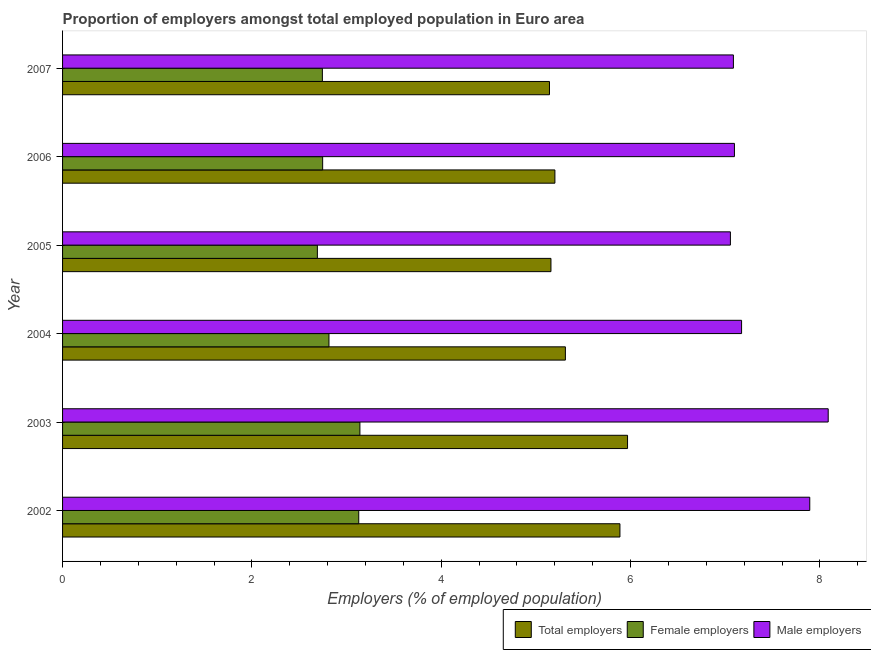How many different coloured bars are there?
Give a very brief answer. 3. How many bars are there on the 6th tick from the bottom?
Offer a very short reply. 3. In how many cases, is the number of bars for a given year not equal to the number of legend labels?
Your response must be concise. 0. What is the percentage of male employers in 2004?
Offer a terse response. 7.17. Across all years, what is the maximum percentage of female employers?
Offer a terse response. 3.14. Across all years, what is the minimum percentage of female employers?
Ensure brevity in your answer.  2.69. In which year was the percentage of female employers minimum?
Give a very brief answer. 2005. What is the total percentage of male employers in the graph?
Your answer should be compact. 44.39. What is the difference between the percentage of total employers in 2002 and that in 2004?
Give a very brief answer. 0.58. What is the difference between the percentage of total employers in 2003 and the percentage of male employers in 2006?
Provide a succinct answer. -1.13. What is the average percentage of female employers per year?
Your answer should be very brief. 2.88. In the year 2007, what is the difference between the percentage of male employers and percentage of female employers?
Your response must be concise. 4.34. What is the ratio of the percentage of total employers in 2003 to that in 2005?
Your response must be concise. 1.16. Is the difference between the percentage of female employers in 2002 and 2006 greater than the difference between the percentage of male employers in 2002 and 2006?
Make the answer very short. No. What is the difference between the highest and the second highest percentage of female employers?
Provide a succinct answer. 0.01. What is the difference between the highest and the lowest percentage of total employers?
Provide a short and direct response. 0.82. Is the sum of the percentage of female employers in 2003 and 2007 greater than the maximum percentage of male employers across all years?
Your response must be concise. No. What does the 3rd bar from the top in 2003 represents?
Ensure brevity in your answer.  Total employers. What does the 3rd bar from the bottom in 2007 represents?
Provide a succinct answer. Male employers. Is it the case that in every year, the sum of the percentage of total employers and percentage of female employers is greater than the percentage of male employers?
Ensure brevity in your answer.  Yes. How many bars are there?
Provide a succinct answer. 18. Does the graph contain any zero values?
Ensure brevity in your answer.  No. Where does the legend appear in the graph?
Give a very brief answer. Bottom right. How are the legend labels stacked?
Your answer should be compact. Horizontal. What is the title of the graph?
Offer a terse response. Proportion of employers amongst total employed population in Euro area. Does "Financial account" appear as one of the legend labels in the graph?
Provide a succinct answer. No. What is the label or title of the X-axis?
Offer a terse response. Employers (% of employed population). What is the label or title of the Y-axis?
Your answer should be very brief. Year. What is the Employers (% of employed population) in Total employers in 2002?
Ensure brevity in your answer.  5.89. What is the Employers (% of employed population) of Female employers in 2002?
Your answer should be very brief. 3.13. What is the Employers (% of employed population) of Male employers in 2002?
Make the answer very short. 7.89. What is the Employers (% of employed population) of Total employers in 2003?
Make the answer very short. 5.97. What is the Employers (% of employed population) in Female employers in 2003?
Your response must be concise. 3.14. What is the Employers (% of employed population) of Male employers in 2003?
Provide a succinct answer. 8.09. What is the Employers (% of employed population) in Total employers in 2004?
Make the answer very short. 5.31. What is the Employers (% of employed population) in Female employers in 2004?
Make the answer very short. 2.81. What is the Employers (% of employed population) of Male employers in 2004?
Keep it short and to the point. 7.17. What is the Employers (% of employed population) of Total employers in 2005?
Your answer should be very brief. 5.16. What is the Employers (% of employed population) in Female employers in 2005?
Keep it short and to the point. 2.69. What is the Employers (% of employed population) of Male employers in 2005?
Provide a succinct answer. 7.05. What is the Employers (% of employed population) in Total employers in 2006?
Offer a very short reply. 5.2. What is the Employers (% of employed population) in Female employers in 2006?
Offer a very short reply. 2.75. What is the Employers (% of employed population) in Male employers in 2006?
Your answer should be compact. 7.1. What is the Employers (% of employed population) in Total employers in 2007?
Make the answer very short. 5.14. What is the Employers (% of employed population) in Female employers in 2007?
Your answer should be compact. 2.74. What is the Employers (% of employed population) of Male employers in 2007?
Provide a short and direct response. 7.09. Across all years, what is the maximum Employers (% of employed population) in Total employers?
Make the answer very short. 5.97. Across all years, what is the maximum Employers (% of employed population) in Female employers?
Make the answer very short. 3.14. Across all years, what is the maximum Employers (% of employed population) in Male employers?
Offer a very short reply. 8.09. Across all years, what is the minimum Employers (% of employed population) of Total employers?
Make the answer very short. 5.14. Across all years, what is the minimum Employers (% of employed population) in Female employers?
Keep it short and to the point. 2.69. Across all years, what is the minimum Employers (% of employed population) in Male employers?
Provide a short and direct response. 7.05. What is the total Employers (% of employed population) in Total employers in the graph?
Your response must be concise. 32.67. What is the total Employers (% of employed population) in Female employers in the graph?
Offer a very short reply. 17.27. What is the total Employers (% of employed population) in Male employers in the graph?
Offer a very short reply. 44.39. What is the difference between the Employers (% of employed population) in Total employers in 2002 and that in 2003?
Offer a terse response. -0.08. What is the difference between the Employers (% of employed population) in Female employers in 2002 and that in 2003?
Your response must be concise. -0.01. What is the difference between the Employers (% of employed population) in Male employers in 2002 and that in 2003?
Your answer should be compact. -0.19. What is the difference between the Employers (% of employed population) in Total employers in 2002 and that in 2004?
Keep it short and to the point. 0.58. What is the difference between the Employers (% of employed population) in Female employers in 2002 and that in 2004?
Offer a terse response. 0.31. What is the difference between the Employers (% of employed population) in Male employers in 2002 and that in 2004?
Offer a very short reply. 0.72. What is the difference between the Employers (% of employed population) in Total employers in 2002 and that in 2005?
Give a very brief answer. 0.73. What is the difference between the Employers (% of employed population) in Female employers in 2002 and that in 2005?
Your answer should be very brief. 0.44. What is the difference between the Employers (% of employed population) in Male employers in 2002 and that in 2005?
Your answer should be very brief. 0.84. What is the difference between the Employers (% of employed population) in Total employers in 2002 and that in 2006?
Make the answer very short. 0.69. What is the difference between the Employers (% of employed population) of Female employers in 2002 and that in 2006?
Your answer should be very brief. 0.38. What is the difference between the Employers (% of employed population) in Male employers in 2002 and that in 2006?
Your response must be concise. 0.8. What is the difference between the Employers (% of employed population) of Total employers in 2002 and that in 2007?
Your answer should be very brief. 0.74. What is the difference between the Employers (% of employed population) of Female employers in 2002 and that in 2007?
Provide a short and direct response. 0.38. What is the difference between the Employers (% of employed population) in Male employers in 2002 and that in 2007?
Keep it short and to the point. 0.81. What is the difference between the Employers (% of employed population) of Total employers in 2003 and that in 2004?
Keep it short and to the point. 0.66. What is the difference between the Employers (% of employed population) of Female employers in 2003 and that in 2004?
Provide a succinct answer. 0.33. What is the difference between the Employers (% of employed population) in Male employers in 2003 and that in 2004?
Keep it short and to the point. 0.92. What is the difference between the Employers (% of employed population) in Total employers in 2003 and that in 2005?
Keep it short and to the point. 0.81. What is the difference between the Employers (% of employed population) in Female employers in 2003 and that in 2005?
Your answer should be very brief. 0.45. What is the difference between the Employers (% of employed population) of Male employers in 2003 and that in 2005?
Your answer should be compact. 1.03. What is the difference between the Employers (% of employed population) of Total employers in 2003 and that in 2006?
Your answer should be compact. 0.77. What is the difference between the Employers (% of employed population) of Female employers in 2003 and that in 2006?
Your answer should be compact. 0.39. What is the difference between the Employers (% of employed population) in Male employers in 2003 and that in 2006?
Provide a succinct answer. 0.99. What is the difference between the Employers (% of employed population) of Total employers in 2003 and that in 2007?
Your answer should be compact. 0.82. What is the difference between the Employers (% of employed population) in Female employers in 2003 and that in 2007?
Ensure brevity in your answer.  0.4. What is the difference between the Employers (% of employed population) of Total employers in 2004 and that in 2005?
Provide a succinct answer. 0.15. What is the difference between the Employers (% of employed population) of Female employers in 2004 and that in 2005?
Offer a very short reply. 0.12. What is the difference between the Employers (% of employed population) in Male employers in 2004 and that in 2005?
Give a very brief answer. 0.12. What is the difference between the Employers (% of employed population) of Total employers in 2004 and that in 2006?
Offer a terse response. 0.11. What is the difference between the Employers (% of employed population) of Female employers in 2004 and that in 2006?
Your answer should be very brief. 0.07. What is the difference between the Employers (% of employed population) of Male employers in 2004 and that in 2006?
Your answer should be very brief. 0.08. What is the difference between the Employers (% of employed population) in Total employers in 2004 and that in 2007?
Give a very brief answer. 0.17. What is the difference between the Employers (% of employed population) of Female employers in 2004 and that in 2007?
Keep it short and to the point. 0.07. What is the difference between the Employers (% of employed population) of Male employers in 2004 and that in 2007?
Make the answer very short. 0.09. What is the difference between the Employers (% of employed population) in Total employers in 2005 and that in 2006?
Provide a short and direct response. -0.04. What is the difference between the Employers (% of employed population) of Female employers in 2005 and that in 2006?
Provide a short and direct response. -0.06. What is the difference between the Employers (% of employed population) of Male employers in 2005 and that in 2006?
Your answer should be compact. -0.04. What is the difference between the Employers (% of employed population) of Total employers in 2005 and that in 2007?
Make the answer very short. 0.02. What is the difference between the Employers (% of employed population) in Female employers in 2005 and that in 2007?
Make the answer very short. -0.05. What is the difference between the Employers (% of employed population) in Male employers in 2005 and that in 2007?
Your answer should be very brief. -0.03. What is the difference between the Employers (% of employed population) in Total employers in 2006 and that in 2007?
Make the answer very short. 0.06. What is the difference between the Employers (% of employed population) in Female employers in 2006 and that in 2007?
Provide a short and direct response. 0. What is the difference between the Employers (% of employed population) in Male employers in 2006 and that in 2007?
Offer a very short reply. 0.01. What is the difference between the Employers (% of employed population) in Total employers in 2002 and the Employers (% of employed population) in Female employers in 2003?
Your response must be concise. 2.75. What is the difference between the Employers (% of employed population) in Total employers in 2002 and the Employers (% of employed population) in Male employers in 2003?
Provide a short and direct response. -2.2. What is the difference between the Employers (% of employed population) of Female employers in 2002 and the Employers (% of employed population) of Male employers in 2003?
Your answer should be compact. -4.96. What is the difference between the Employers (% of employed population) of Total employers in 2002 and the Employers (% of employed population) of Female employers in 2004?
Keep it short and to the point. 3.07. What is the difference between the Employers (% of employed population) in Total employers in 2002 and the Employers (% of employed population) in Male employers in 2004?
Ensure brevity in your answer.  -1.28. What is the difference between the Employers (% of employed population) of Female employers in 2002 and the Employers (% of employed population) of Male employers in 2004?
Make the answer very short. -4.04. What is the difference between the Employers (% of employed population) in Total employers in 2002 and the Employers (% of employed population) in Female employers in 2005?
Provide a succinct answer. 3.2. What is the difference between the Employers (% of employed population) in Total employers in 2002 and the Employers (% of employed population) in Male employers in 2005?
Offer a very short reply. -1.17. What is the difference between the Employers (% of employed population) of Female employers in 2002 and the Employers (% of employed population) of Male employers in 2005?
Give a very brief answer. -3.93. What is the difference between the Employers (% of employed population) of Total employers in 2002 and the Employers (% of employed population) of Female employers in 2006?
Provide a succinct answer. 3.14. What is the difference between the Employers (% of employed population) of Total employers in 2002 and the Employers (% of employed population) of Male employers in 2006?
Your response must be concise. -1.21. What is the difference between the Employers (% of employed population) in Female employers in 2002 and the Employers (% of employed population) in Male employers in 2006?
Provide a short and direct response. -3.97. What is the difference between the Employers (% of employed population) of Total employers in 2002 and the Employers (% of employed population) of Female employers in 2007?
Ensure brevity in your answer.  3.14. What is the difference between the Employers (% of employed population) in Total employers in 2002 and the Employers (% of employed population) in Male employers in 2007?
Ensure brevity in your answer.  -1.2. What is the difference between the Employers (% of employed population) of Female employers in 2002 and the Employers (% of employed population) of Male employers in 2007?
Your answer should be compact. -3.96. What is the difference between the Employers (% of employed population) of Total employers in 2003 and the Employers (% of employed population) of Female employers in 2004?
Your answer should be very brief. 3.15. What is the difference between the Employers (% of employed population) of Total employers in 2003 and the Employers (% of employed population) of Male employers in 2004?
Your answer should be very brief. -1.2. What is the difference between the Employers (% of employed population) in Female employers in 2003 and the Employers (% of employed population) in Male employers in 2004?
Give a very brief answer. -4.03. What is the difference between the Employers (% of employed population) of Total employers in 2003 and the Employers (% of employed population) of Female employers in 2005?
Your response must be concise. 3.28. What is the difference between the Employers (% of employed population) in Total employers in 2003 and the Employers (% of employed population) in Male employers in 2005?
Keep it short and to the point. -1.09. What is the difference between the Employers (% of employed population) in Female employers in 2003 and the Employers (% of employed population) in Male employers in 2005?
Provide a succinct answer. -3.91. What is the difference between the Employers (% of employed population) of Total employers in 2003 and the Employers (% of employed population) of Female employers in 2006?
Your response must be concise. 3.22. What is the difference between the Employers (% of employed population) of Total employers in 2003 and the Employers (% of employed population) of Male employers in 2006?
Ensure brevity in your answer.  -1.13. What is the difference between the Employers (% of employed population) of Female employers in 2003 and the Employers (% of employed population) of Male employers in 2006?
Your response must be concise. -3.96. What is the difference between the Employers (% of employed population) in Total employers in 2003 and the Employers (% of employed population) in Female employers in 2007?
Keep it short and to the point. 3.22. What is the difference between the Employers (% of employed population) in Total employers in 2003 and the Employers (% of employed population) in Male employers in 2007?
Your response must be concise. -1.12. What is the difference between the Employers (% of employed population) in Female employers in 2003 and the Employers (% of employed population) in Male employers in 2007?
Ensure brevity in your answer.  -3.95. What is the difference between the Employers (% of employed population) of Total employers in 2004 and the Employers (% of employed population) of Female employers in 2005?
Offer a very short reply. 2.62. What is the difference between the Employers (% of employed population) in Total employers in 2004 and the Employers (% of employed population) in Male employers in 2005?
Offer a terse response. -1.74. What is the difference between the Employers (% of employed population) of Female employers in 2004 and the Employers (% of employed population) of Male employers in 2005?
Give a very brief answer. -4.24. What is the difference between the Employers (% of employed population) in Total employers in 2004 and the Employers (% of employed population) in Female employers in 2006?
Provide a succinct answer. 2.56. What is the difference between the Employers (% of employed population) of Total employers in 2004 and the Employers (% of employed population) of Male employers in 2006?
Provide a succinct answer. -1.79. What is the difference between the Employers (% of employed population) of Female employers in 2004 and the Employers (% of employed population) of Male employers in 2006?
Ensure brevity in your answer.  -4.28. What is the difference between the Employers (% of employed population) of Total employers in 2004 and the Employers (% of employed population) of Female employers in 2007?
Make the answer very short. 2.57. What is the difference between the Employers (% of employed population) of Total employers in 2004 and the Employers (% of employed population) of Male employers in 2007?
Your answer should be compact. -1.77. What is the difference between the Employers (% of employed population) of Female employers in 2004 and the Employers (% of employed population) of Male employers in 2007?
Provide a succinct answer. -4.27. What is the difference between the Employers (% of employed population) of Total employers in 2005 and the Employers (% of employed population) of Female employers in 2006?
Give a very brief answer. 2.41. What is the difference between the Employers (% of employed population) in Total employers in 2005 and the Employers (% of employed population) in Male employers in 2006?
Your answer should be very brief. -1.94. What is the difference between the Employers (% of employed population) of Female employers in 2005 and the Employers (% of employed population) of Male employers in 2006?
Provide a short and direct response. -4.41. What is the difference between the Employers (% of employed population) of Total employers in 2005 and the Employers (% of employed population) of Female employers in 2007?
Make the answer very short. 2.41. What is the difference between the Employers (% of employed population) in Total employers in 2005 and the Employers (% of employed population) in Male employers in 2007?
Offer a terse response. -1.93. What is the difference between the Employers (% of employed population) in Female employers in 2005 and the Employers (% of employed population) in Male employers in 2007?
Make the answer very short. -4.39. What is the difference between the Employers (% of employed population) in Total employers in 2006 and the Employers (% of employed population) in Female employers in 2007?
Offer a very short reply. 2.46. What is the difference between the Employers (% of employed population) of Total employers in 2006 and the Employers (% of employed population) of Male employers in 2007?
Ensure brevity in your answer.  -1.89. What is the difference between the Employers (% of employed population) in Female employers in 2006 and the Employers (% of employed population) in Male employers in 2007?
Offer a terse response. -4.34. What is the average Employers (% of employed population) in Total employers per year?
Offer a very short reply. 5.45. What is the average Employers (% of employed population) of Female employers per year?
Provide a succinct answer. 2.88. What is the average Employers (% of employed population) in Male employers per year?
Keep it short and to the point. 7.4. In the year 2002, what is the difference between the Employers (% of employed population) in Total employers and Employers (% of employed population) in Female employers?
Provide a succinct answer. 2.76. In the year 2002, what is the difference between the Employers (% of employed population) of Total employers and Employers (% of employed population) of Male employers?
Offer a very short reply. -2.01. In the year 2002, what is the difference between the Employers (% of employed population) in Female employers and Employers (% of employed population) in Male employers?
Your answer should be very brief. -4.76. In the year 2003, what is the difference between the Employers (% of employed population) of Total employers and Employers (% of employed population) of Female employers?
Make the answer very short. 2.83. In the year 2003, what is the difference between the Employers (% of employed population) in Total employers and Employers (% of employed population) in Male employers?
Your response must be concise. -2.12. In the year 2003, what is the difference between the Employers (% of employed population) in Female employers and Employers (% of employed population) in Male employers?
Keep it short and to the point. -4.95. In the year 2004, what is the difference between the Employers (% of employed population) of Total employers and Employers (% of employed population) of Female employers?
Make the answer very short. 2.5. In the year 2004, what is the difference between the Employers (% of employed population) of Total employers and Employers (% of employed population) of Male employers?
Provide a short and direct response. -1.86. In the year 2004, what is the difference between the Employers (% of employed population) of Female employers and Employers (% of employed population) of Male employers?
Offer a very short reply. -4.36. In the year 2005, what is the difference between the Employers (% of employed population) of Total employers and Employers (% of employed population) of Female employers?
Offer a terse response. 2.47. In the year 2005, what is the difference between the Employers (% of employed population) in Total employers and Employers (% of employed population) in Male employers?
Make the answer very short. -1.9. In the year 2005, what is the difference between the Employers (% of employed population) in Female employers and Employers (% of employed population) in Male employers?
Your answer should be compact. -4.36. In the year 2006, what is the difference between the Employers (% of employed population) of Total employers and Employers (% of employed population) of Female employers?
Provide a short and direct response. 2.45. In the year 2006, what is the difference between the Employers (% of employed population) of Total employers and Employers (% of employed population) of Male employers?
Provide a short and direct response. -1.9. In the year 2006, what is the difference between the Employers (% of employed population) of Female employers and Employers (% of employed population) of Male employers?
Offer a very short reply. -4.35. In the year 2007, what is the difference between the Employers (% of employed population) of Total employers and Employers (% of employed population) of Female employers?
Make the answer very short. 2.4. In the year 2007, what is the difference between the Employers (% of employed population) in Total employers and Employers (% of employed population) in Male employers?
Your answer should be compact. -1.94. In the year 2007, what is the difference between the Employers (% of employed population) of Female employers and Employers (% of employed population) of Male employers?
Keep it short and to the point. -4.34. What is the ratio of the Employers (% of employed population) in Total employers in 2002 to that in 2003?
Offer a very short reply. 0.99. What is the ratio of the Employers (% of employed population) in Male employers in 2002 to that in 2003?
Make the answer very short. 0.98. What is the ratio of the Employers (% of employed population) in Total employers in 2002 to that in 2004?
Your response must be concise. 1.11. What is the ratio of the Employers (% of employed population) in Female employers in 2002 to that in 2004?
Provide a short and direct response. 1.11. What is the ratio of the Employers (% of employed population) of Male employers in 2002 to that in 2004?
Provide a succinct answer. 1.1. What is the ratio of the Employers (% of employed population) in Total employers in 2002 to that in 2005?
Offer a very short reply. 1.14. What is the ratio of the Employers (% of employed population) in Female employers in 2002 to that in 2005?
Offer a very short reply. 1.16. What is the ratio of the Employers (% of employed population) in Male employers in 2002 to that in 2005?
Keep it short and to the point. 1.12. What is the ratio of the Employers (% of employed population) of Total employers in 2002 to that in 2006?
Offer a very short reply. 1.13. What is the ratio of the Employers (% of employed population) in Female employers in 2002 to that in 2006?
Give a very brief answer. 1.14. What is the ratio of the Employers (% of employed population) of Male employers in 2002 to that in 2006?
Provide a short and direct response. 1.11. What is the ratio of the Employers (% of employed population) in Total employers in 2002 to that in 2007?
Your answer should be compact. 1.14. What is the ratio of the Employers (% of employed population) in Female employers in 2002 to that in 2007?
Give a very brief answer. 1.14. What is the ratio of the Employers (% of employed population) in Male employers in 2002 to that in 2007?
Keep it short and to the point. 1.11. What is the ratio of the Employers (% of employed population) in Total employers in 2003 to that in 2004?
Provide a short and direct response. 1.12. What is the ratio of the Employers (% of employed population) in Female employers in 2003 to that in 2004?
Your response must be concise. 1.12. What is the ratio of the Employers (% of employed population) of Male employers in 2003 to that in 2004?
Provide a short and direct response. 1.13. What is the ratio of the Employers (% of employed population) in Total employers in 2003 to that in 2005?
Your response must be concise. 1.16. What is the ratio of the Employers (% of employed population) of Female employers in 2003 to that in 2005?
Offer a very short reply. 1.17. What is the ratio of the Employers (% of employed population) in Male employers in 2003 to that in 2005?
Your answer should be very brief. 1.15. What is the ratio of the Employers (% of employed population) of Total employers in 2003 to that in 2006?
Your answer should be very brief. 1.15. What is the ratio of the Employers (% of employed population) of Female employers in 2003 to that in 2006?
Provide a succinct answer. 1.14. What is the ratio of the Employers (% of employed population) of Male employers in 2003 to that in 2006?
Keep it short and to the point. 1.14. What is the ratio of the Employers (% of employed population) of Total employers in 2003 to that in 2007?
Your response must be concise. 1.16. What is the ratio of the Employers (% of employed population) of Female employers in 2003 to that in 2007?
Your answer should be compact. 1.14. What is the ratio of the Employers (% of employed population) in Male employers in 2003 to that in 2007?
Offer a very short reply. 1.14. What is the ratio of the Employers (% of employed population) of Total employers in 2004 to that in 2005?
Your response must be concise. 1.03. What is the ratio of the Employers (% of employed population) in Female employers in 2004 to that in 2005?
Provide a succinct answer. 1.05. What is the ratio of the Employers (% of employed population) of Male employers in 2004 to that in 2005?
Ensure brevity in your answer.  1.02. What is the ratio of the Employers (% of employed population) in Total employers in 2004 to that in 2006?
Make the answer very short. 1.02. What is the ratio of the Employers (% of employed population) of Female employers in 2004 to that in 2006?
Provide a short and direct response. 1.02. What is the ratio of the Employers (% of employed population) of Male employers in 2004 to that in 2006?
Give a very brief answer. 1.01. What is the ratio of the Employers (% of employed population) in Total employers in 2004 to that in 2007?
Your response must be concise. 1.03. What is the ratio of the Employers (% of employed population) in Female employers in 2004 to that in 2007?
Provide a succinct answer. 1.03. What is the ratio of the Employers (% of employed population) in Male employers in 2004 to that in 2007?
Your answer should be very brief. 1.01. What is the ratio of the Employers (% of employed population) in Total employers in 2005 to that in 2006?
Your answer should be very brief. 0.99. What is the ratio of the Employers (% of employed population) in Female employers in 2005 to that in 2006?
Keep it short and to the point. 0.98. What is the ratio of the Employers (% of employed population) of Female employers in 2005 to that in 2007?
Keep it short and to the point. 0.98. What is the ratio of the Employers (% of employed population) in Total employers in 2006 to that in 2007?
Your response must be concise. 1.01. What is the difference between the highest and the second highest Employers (% of employed population) in Total employers?
Ensure brevity in your answer.  0.08. What is the difference between the highest and the second highest Employers (% of employed population) of Female employers?
Provide a short and direct response. 0.01. What is the difference between the highest and the second highest Employers (% of employed population) in Male employers?
Make the answer very short. 0.19. What is the difference between the highest and the lowest Employers (% of employed population) of Total employers?
Ensure brevity in your answer.  0.82. What is the difference between the highest and the lowest Employers (% of employed population) of Female employers?
Provide a succinct answer. 0.45. What is the difference between the highest and the lowest Employers (% of employed population) of Male employers?
Provide a succinct answer. 1.03. 